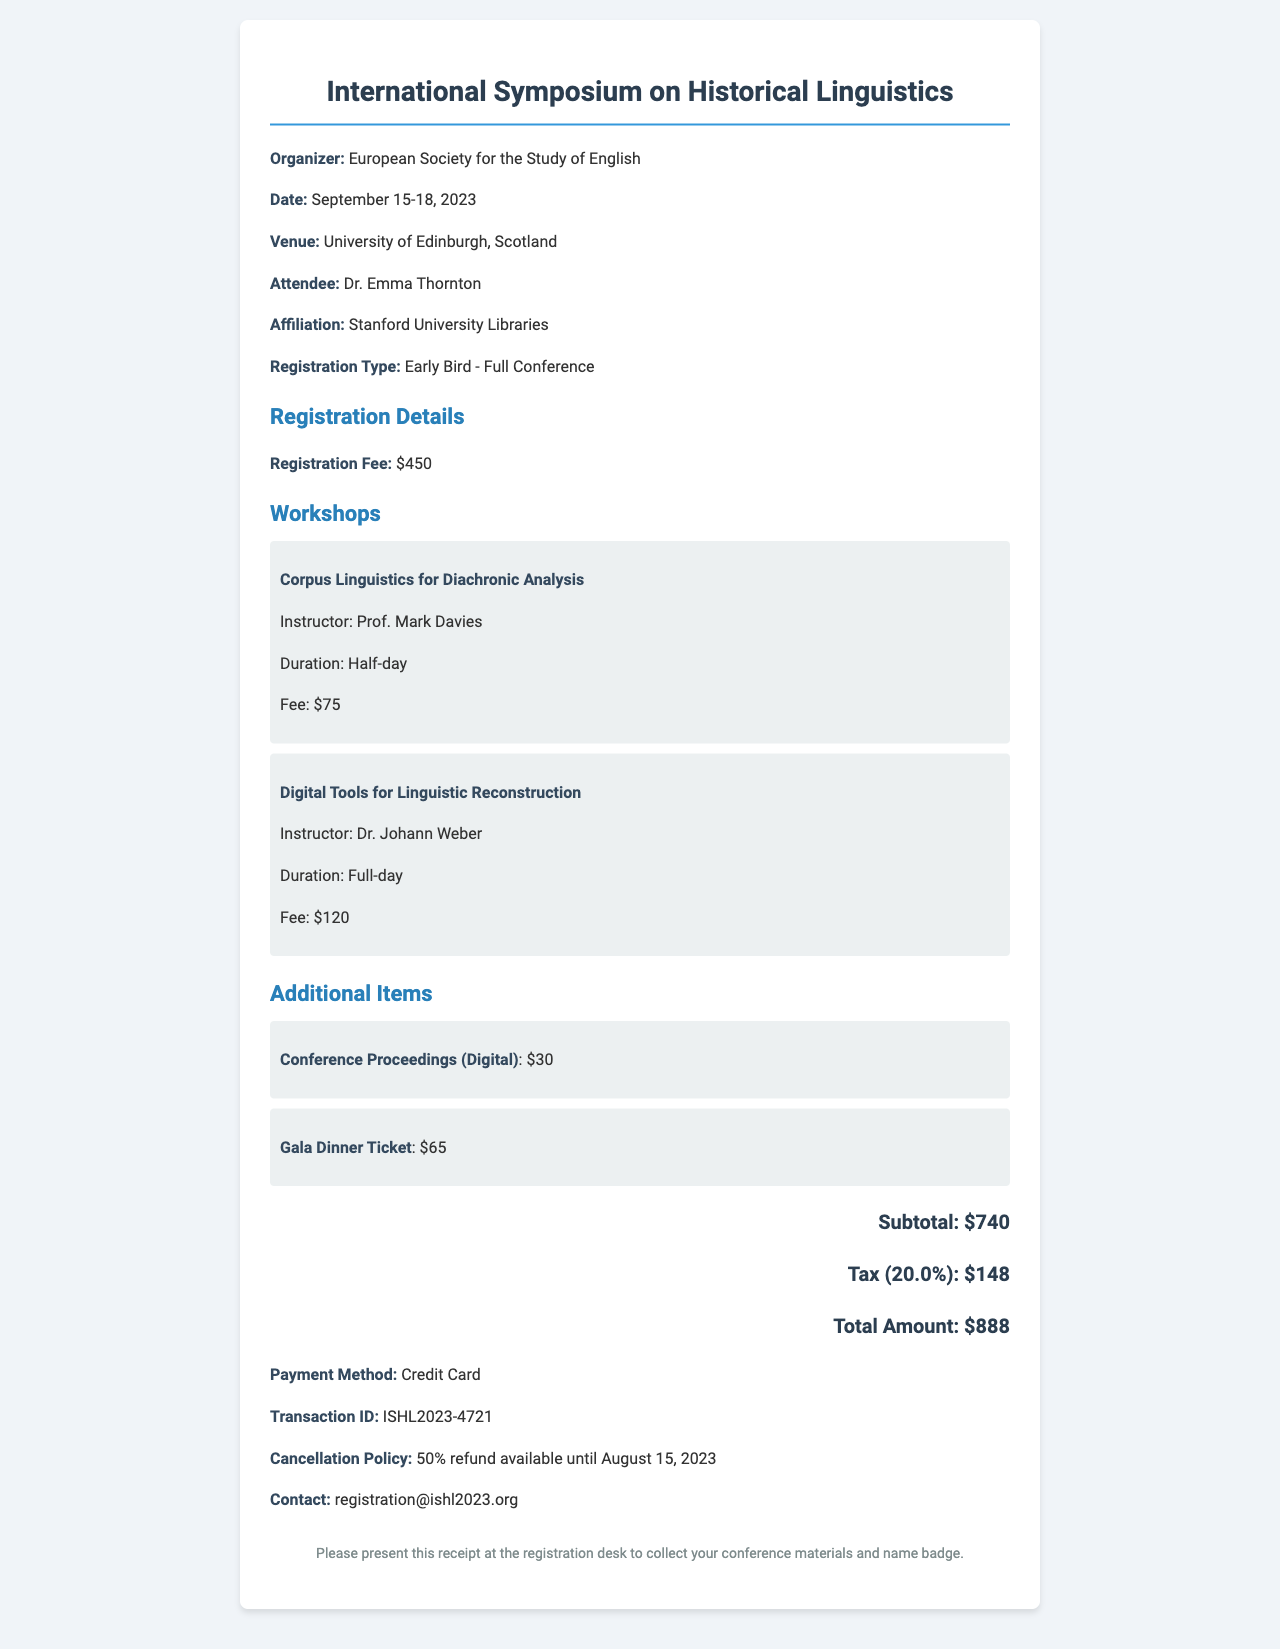What is the name of the conference? The name of the conference is prominently listed at the top of the document as part of the conference details.
Answer: International Symposium on Historical Linguistics What is the total amount paid? The total amount paid is calculated and shown at the bottom of the receipt, summarizing the costs including registration and fees.
Answer: 888 Who is the instructor for the workshop on Digital Tools for Linguistic Reconstruction? The instructor's name for that specific workshop is listed in the workshop details section of the document.
Answer: Dr. Johann Weber What is the cancellation policy? The cancellation policy can be found in the info group section of the receipt that explains the refund conditions.
Answer: 50% refund available until August 15, 2023 How much is the registration fee? The registration fee is specifically mentioned as part of the registration details, highlighting the cost for attending the conference.
Answer: 450 What is the duration of the workshop "Corpus Linguistics for Diachronic Analysis"? The duration of this workshop is stated in the workshop details section of the document.
Answer: Half-day What are the additional items purchased? The additional items section of the receipt clearly lists any additional products or services that were included in the registration.
Answer: Conference Proceedings (Digital), Gala Dinner Ticket What payment method was used? The payment method is explicitly mentioned in the info group, detailing how the attendee completed the transaction.
Answer: Credit Card What is the transaction ID for the registration? The transaction ID is a unique reference listed in the info group section of the receipt for tracking the payment.
Answer: ISHL2023-4721 